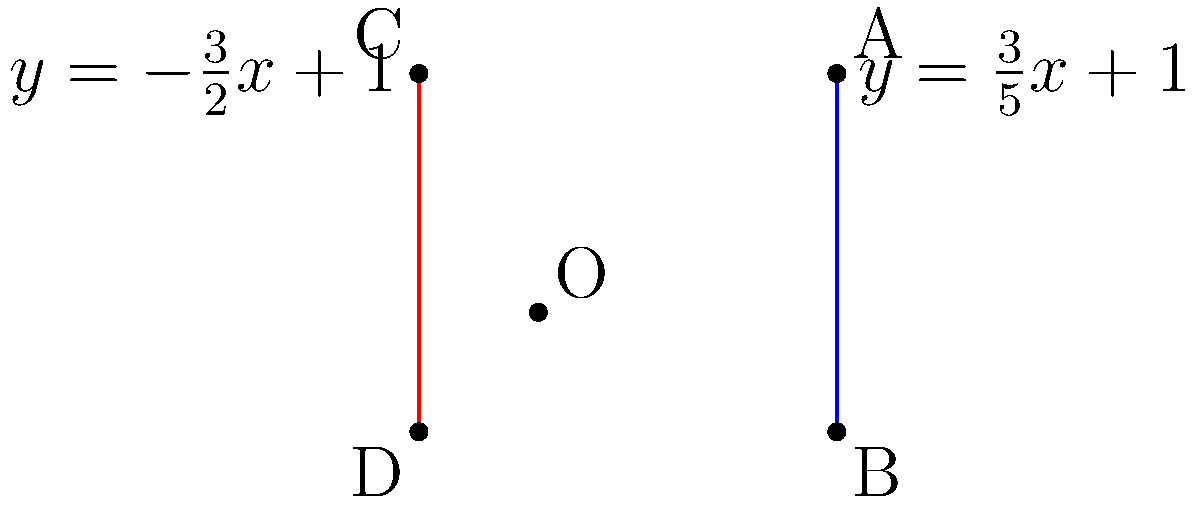As an international recruiter, you're tasked with evaluating a candidate's analytical skills. The candidate claims to have expertise in analytic geometry. To verify this, you present them with the following problem:

Two lines intersect as shown in the diagram. Line 1 (blue) has the equation $y=\frac{3}{5}x+1$, and Line 2 (red) has the equation $y=-\frac{3}{2}x+1$. Calculate the acute angle between these two lines. To find the angle between two intersecting lines, we can use the following steps:

1) The general formula for the angle $\theta$ between two lines with slopes $m_1$ and $m_2$ is:

   $$\tan \theta = \left|\frac{m_2 - m_1}{1 + m_1m_2}\right|$$

2) From the given equations:
   For Line 1: $y=\frac{3}{5}x+1$, so $m_1 = \frac{3}{5}$
   For Line 2: $y=-\frac{3}{2}x+1$, so $m_2 = -\frac{3}{2}$

3) Substituting these values into the formula:

   $$\tan \theta = \left|\frac{-\frac{3}{2} - \frac{3}{5}}{1 + (\frac{3}{5})(-\frac{3}{2})}\right|$$

4) Simplify the numerator and denominator:
   
   $$\tan \theta = \left|\frac{-\frac{15}{10} - \frac{6}{10}}{1 - \frac{9}{10}}\right| = \left|\frac{-\frac{21}{10}}{\frac{1}{10}}\right| = 21$$

5) To find $\theta$, we need to calculate the inverse tangent (arctangent):

   $$\theta = \arctan(21)$$

6) Using a calculator or computational tool:

   $$\theta \approx 87.27^\circ$$

This is the acute angle between the two lines.
Answer: $87.27^\circ$ 